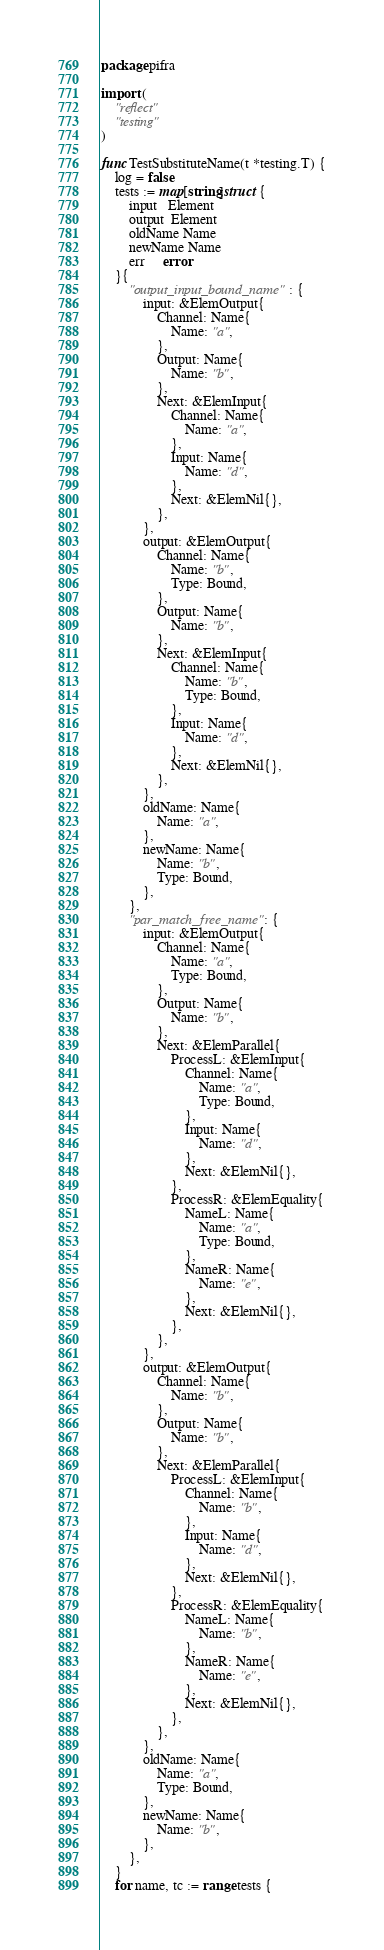<code> <loc_0><loc_0><loc_500><loc_500><_Go_>package pifra

import (
	"reflect"
	"testing"
)

func TestSubstituteName(t *testing.T) {
	log = false
	tests := map[string]struct {
		input   Element
		output  Element
		oldName Name
		newName Name
		err     error
	}{
		"output_input_bound_name": {
			input: &ElemOutput{
				Channel: Name{
					Name: "a",
				},
				Output: Name{
					Name: "b",
				},
				Next: &ElemInput{
					Channel: Name{
						Name: "a",
					},
					Input: Name{
						Name: "d",
					},
					Next: &ElemNil{},
				},
			},
			output: &ElemOutput{
				Channel: Name{
					Name: "b",
					Type: Bound,
				},
				Output: Name{
					Name: "b",
				},
				Next: &ElemInput{
					Channel: Name{
						Name: "b",
						Type: Bound,
					},
					Input: Name{
						Name: "d",
					},
					Next: &ElemNil{},
				},
			},
			oldName: Name{
				Name: "a",
			},
			newName: Name{
				Name: "b",
				Type: Bound,
			},
		},
		"par_match_free_name": {
			input: &ElemOutput{
				Channel: Name{
					Name: "a",
					Type: Bound,
				},
				Output: Name{
					Name: "b",
				},
				Next: &ElemParallel{
					ProcessL: &ElemInput{
						Channel: Name{
							Name: "a",
							Type: Bound,
						},
						Input: Name{
							Name: "d",
						},
						Next: &ElemNil{},
					},
					ProcessR: &ElemEquality{
						NameL: Name{
							Name: "a",
							Type: Bound,
						},
						NameR: Name{
							Name: "e",
						},
						Next: &ElemNil{},
					},
				},
			},
			output: &ElemOutput{
				Channel: Name{
					Name: "b",
				},
				Output: Name{
					Name: "b",
				},
				Next: &ElemParallel{
					ProcessL: &ElemInput{
						Channel: Name{
							Name: "b",
						},
						Input: Name{
							Name: "d",
						},
						Next: &ElemNil{},
					},
					ProcessR: &ElemEquality{
						NameL: Name{
							Name: "b",
						},
						NameR: Name{
							Name: "e",
						},
						Next: &ElemNil{},
					},
				},
			},
			oldName: Name{
				Name: "a",
				Type: Bound,
			},
			newName: Name{
				Name: "b",
			},
		},
	}
	for name, tc := range tests {</code> 